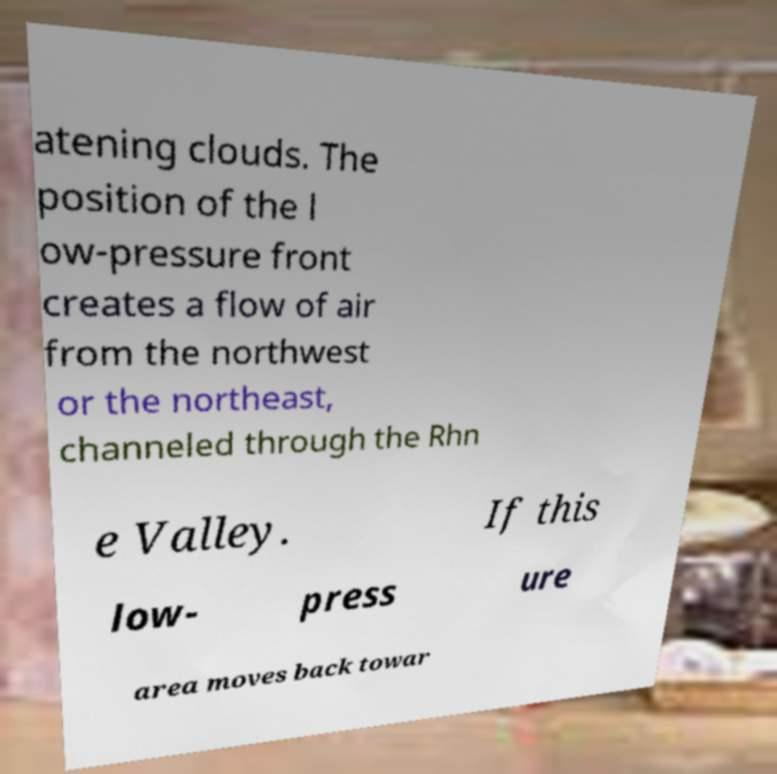Please identify and transcribe the text found in this image. atening clouds. The position of the l ow-pressure front creates a flow of air from the northwest or the northeast, channeled through the Rhn e Valley. If this low- press ure area moves back towar 